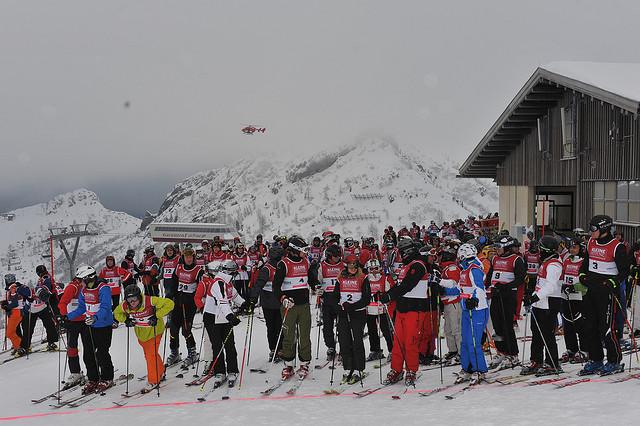How many skis are in the photo?
Concise answer only. Lot. Is the snow deep?
Short answer required. No. Are they skiing?
Write a very short answer. Yes. What is the brown building behind the people used for?
Short answer required. Lodge. What kind of event is happening?
Write a very short answer. Skiing. 